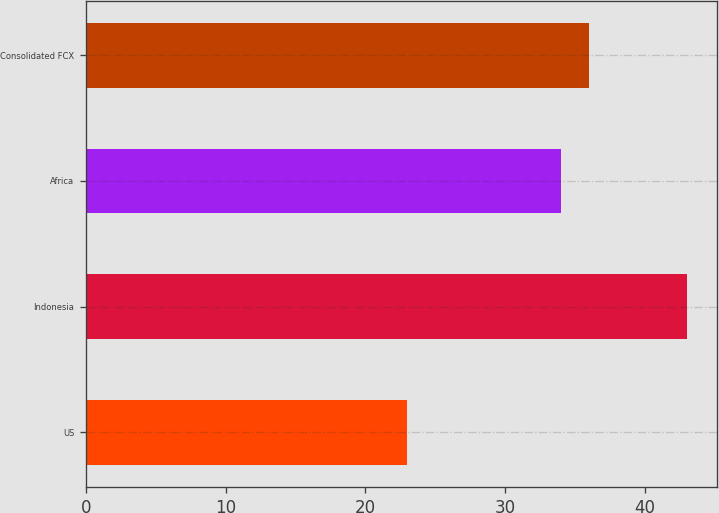Convert chart to OTSL. <chart><loc_0><loc_0><loc_500><loc_500><bar_chart><fcel>US<fcel>Indonesia<fcel>Africa<fcel>Consolidated FCX<nl><fcel>23<fcel>43<fcel>34<fcel>36<nl></chart> 